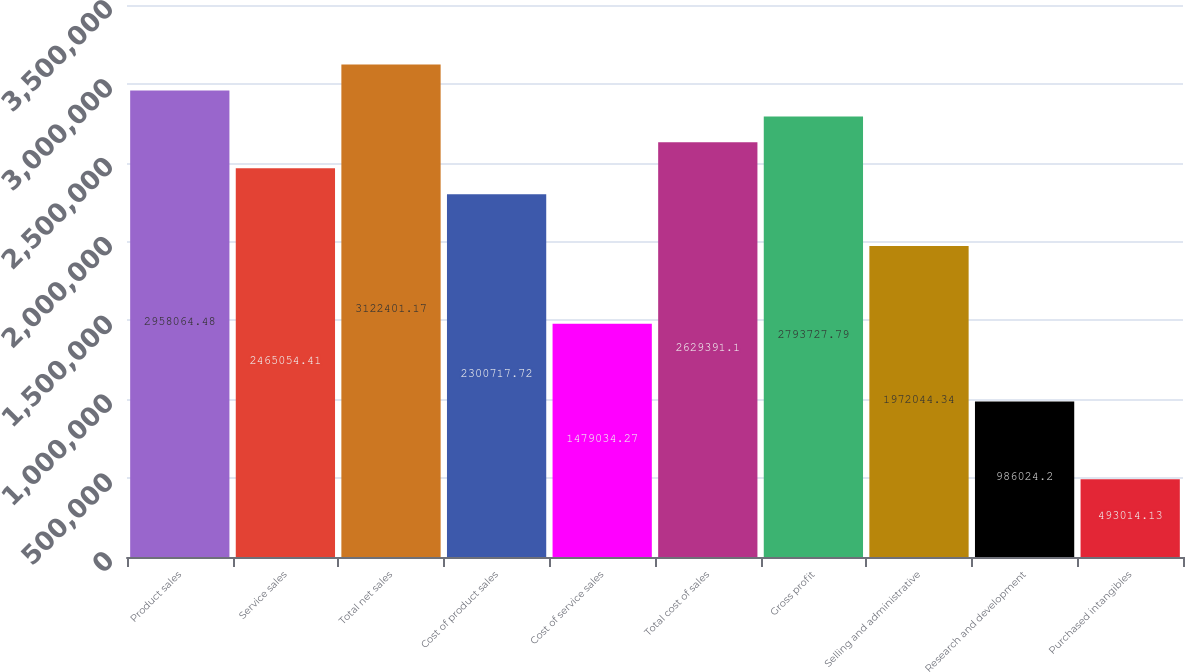Convert chart. <chart><loc_0><loc_0><loc_500><loc_500><bar_chart><fcel>Product sales<fcel>Service sales<fcel>Total net sales<fcel>Cost of product sales<fcel>Cost of service sales<fcel>Total cost of sales<fcel>Gross profit<fcel>Selling and administrative<fcel>Research and development<fcel>Purchased intangibles<nl><fcel>2.95806e+06<fcel>2.46505e+06<fcel>3.1224e+06<fcel>2.30072e+06<fcel>1.47903e+06<fcel>2.62939e+06<fcel>2.79373e+06<fcel>1.97204e+06<fcel>986024<fcel>493014<nl></chart> 